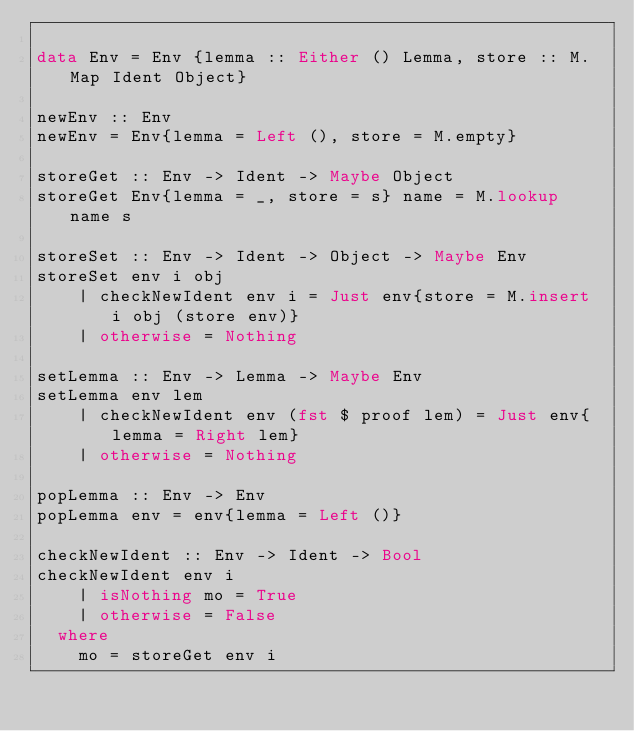<code> <loc_0><loc_0><loc_500><loc_500><_Haskell_>
data Env = Env {lemma :: Either () Lemma, store :: M.Map Ident Object}

newEnv :: Env
newEnv = Env{lemma = Left (), store = M.empty}

storeGet :: Env -> Ident -> Maybe Object
storeGet Env{lemma = _, store = s} name = M.lookup name s

storeSet :: Env -> Ident -> Object -> Maybe Env
storeSet env i obj
    | checkNewIdent env i = Just env{store = M.insert i obj (store env)}
    | otherwise = Nothing

setLemma :: Env -> Lemma -> Maybe Env
setLemma env lem
    | checkNewIdent env (fst $ proof lem) = Just env{lemma = Right lem}
    | otherwise = Nothing

popLemma :: Env -> Env
popLemma env = env{lemma = Left ()}

checkNewIdent :: Env -> Ident -> Bool
checkNewIdent env i
    | isNothing mo = True
    | otherwise = False
  where
    mo = storeGet env i
</code> 